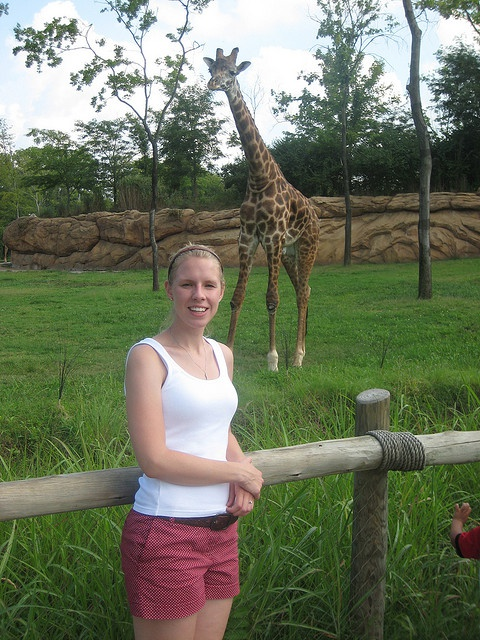Describe the objects in this image and their specific colors. I can see people in lightblue, lavender, brown, lightpink, and maroon tones, giraffe in lightblue, gray, darkgreen, and black tones, and people in lightblue, black, maroon, and gray tones in this image. 